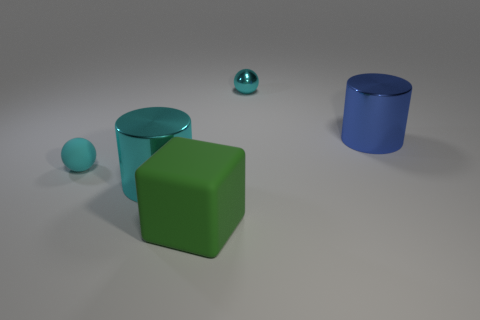Add 3 green cubes. How many objects exist? 8 Subtract 1 blocks. How many blocks are left? 0 Subtract all cyan cylinders. How many cylinders are left? 1 Subtract all small red balls. Subtract all cyan metal cylinders. How many objects are left? 4 Add 3 big green things. How many big green things are left? 4 Add 4 small cyan shiny balls. How many small cyan shiny balls exist? 5 Subtract 0 yellow cylinders. How many objects are left? 5 Subtract all balls. How many objects are left? 3 Subtract all purple spheres. Subtract all red blocks. How many spheres are left? 2 Subtract all green cylinders. How many red spheres are left? 0 